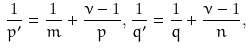Convert formula to latex. <formula><loc_0><loc_0><loc_500><loc_500>\frac { 1 } { p ^ { \prime } } = \frac { 1 } { m } + \frac { \nu - 1 } { p } , \frac { 1 } { q ^ { \prime } } = \frac { 1 } { q } + \frac { \nu - 1 } { n } ,</formula> 